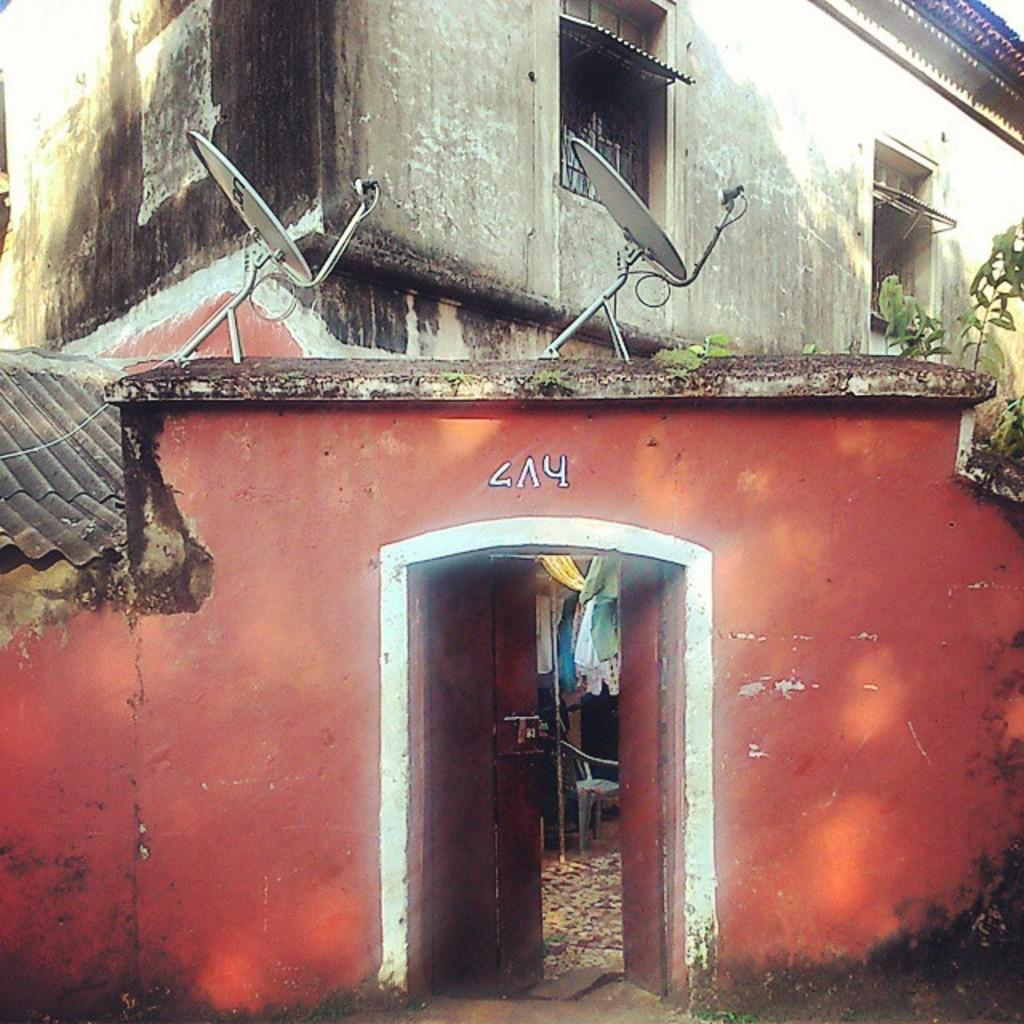What colors are used to paint the building in the image? The building in the image is orange, black, and ash in color. What features can be seen on the building? There are two antennas on the building. What type of vegetation is visible in the image? There is a plant visible in the image. How many windows are on the building? There are windows on the building. What type of fang can be seen on the building in the image? There are no fangs present on the building in the image. How many bees are visible on the plant in the image? There are no bees visible on the plant in the image. 